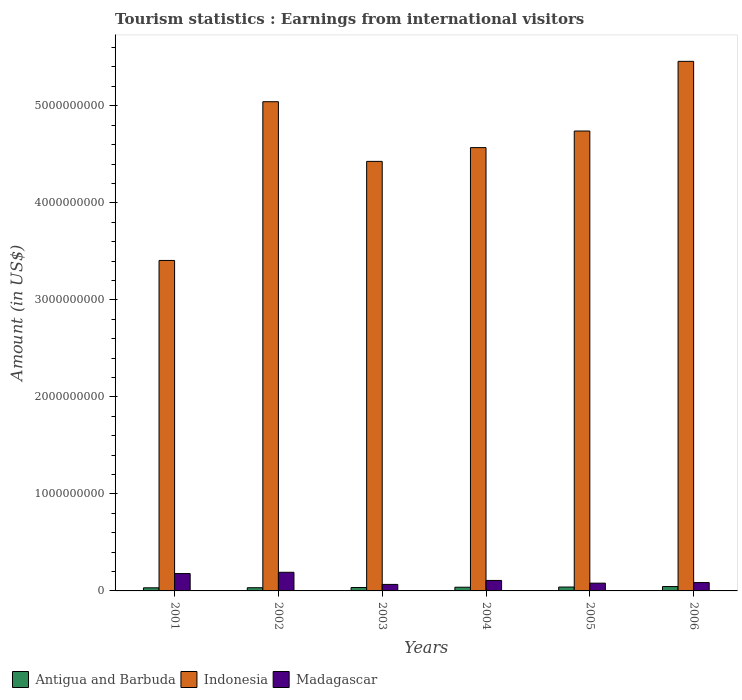How many groups of bars are there?
Keep it short and to the point. 6. How many bars are there on the 3rd tick from the right?
Keep it short and to the point. 3. What is the label of the 3rd group of bars from the left?
Your answer should be very brief. 2003. In how many cases, is the number of bars for a given year not equal to the number of legend labels?
Keep it short and to the point. 0. What is the earnings from international visitors in Indonesia in 2003?
Your answer should be compact. 4.43e+09. Across all years, what is the maximum earnings from international visitors in Antigua and Barbuda?
Provide a succinct answer. 4.50e+07. Across all years, what is the minimum earnings from international visitors in Madagascar?
Make the answer very short. 6.70e+07. What is the total earnings from international visitors in Antigua and Barbuda in the graph?
Your response must be concise. 2.23e+08. What is the difference between the earnings from international visitors in Indonesia in 2001 and that in 2003?
Your answer should be compact. -1.02e+09. What is the difference between the earnings from international visitors in Antigua and Barbuda in 2005 and the earnings from international visitors in Indonesia in 2003?
Offer a terse response. -4.39e+09. What is the average earnings from international visitors in Antigua and Barbuda per year?
Keep it short and to the point. 3.72e+07. In the year 2006, what is the difference between the earnings from international visitors in Antigua and Barbuda and earnings from international visitors in Madagascar?
Make the answer very short. -4.10e+07. In how many years, is the earnings from international visitors in Madagascar greater than 200000000 US$?
Ensure brevity in your answer.  0. What is the ratio of the earnings from international visitors in Madagascar in 2002 to that in 2006?
Your answer should be very brief. 2.23. Is the earnings from international visitors in Madagascar in 2004 less than that in 2005?
Provide a short and direct response. No. Is the difference between the earnings from international visitors in Antigua and Barbuda in 2002 and 2004 greater than the difference between the earnings from international visitors in Madagascar in 2002 and 2004?
Offer a very short reply. No. What is the difference between the highest and the lowest earnings from international visitors in Indonesia?
Offer a very short reply. 2.05e+09. What does the 3rd bar from the left in 2002 represents?
Give a very brief answer. Madagascar. What does the 1st bar from the right in 2006 represents?
Your answer should be compact. Madagascar. Is it the case that in every year, the sum of the earnings from international visitors in Antigua and Barbuda and earnings from international visitors in Madagascar is greater than the earnings from international visitors in Indonesia?
Your answer should be very brief. No. How many years are there in the graph?
Give a very brief answer. 6. What is the difference between two consecutive major ticks on the Y-axis?
Offer a very short reply. 1.00e+09. Does the graph contain any zero values?
Your response must be concise. No. Does the graph contain grids?
Your answer should be very brief. No. How many legend labels are there?
Keep it short and to the point. 3. What is the title of the graph?
Provide a succinct answer. Tourism statistics : Earnings from international visitors. What is the Amount (in US$) in Antigua and Barbuda in 2001?
Your answer should be very brief. 3.20e+07. What is the Amount (in US$) of Indonesia in 2001?
Your response must be concise. 3.41e+09. What is the Amount (in US$) of Madagascar in 2001?
Provide a short and direct response. 1.79e+08. What is the Amount (in US$) in Antigua and Barbuda in 2002?
Provide a succinct answer. 3.30e+07. What is the Amount (in US$) of Indonesia in 2002?
Provide a succinct answer. 5.04e+09. What is the Amount (in US$) of Madagascar in 2002?
Your answer should be compact. 1.92e+08. What is the Amount (in US$) in Antigua and Barbuda in 2003?
Give a very brief answer. 3.50e+07. What is the Amount (in US$) of Indonesia in 2003?
Make the answer very short. 4.43e+09. What is the Amount (in US$) of Madagascar in 2003?
Ensure brevity in your answer.  6.70e+07. What is the Amount (in US$) in Antigua and Barbuda in 2004?
Your response must be concise. 3.80e+07. What is the Amount (in US$) in Indonesia in 2004?
Make the answer very short. 4.57e+09. What is the Amount (in US$) in Madagascar in 2004?
Provide a short and direct response. 1.08e+08. What is the Amount (in US$) of Antigua and Barbuda in 2005?
Make the answer very short. 4.00e+07. What is the Amount (in US$) in Indonesia in 2005?
Your answer should be very brief. 4.74e+09. What is the Amount (in US$) of Madagascar in 2005?
Offer a terse response. 8.00e+07. What is the Amount (in US$) of Antigua and Barbuda in 2006?
Ensure brevity in your answer.  4.50e+07. What is the Amount (in US$) of Indonesia in 2006?
Offer a very short reply. 5.46e+09. What is the Amount (in US$) of Madagascar in 2006?
Provide a short and direct response. 8.60e+07. Across all years, what is the maximum Amount (in US$) of Antigua and Barbuda?
Ensure brevity in your answer.  4.50e+07. Across all years, what is the maximum Amount (in US$) of Indonesia?
Offer a terse response. 5.46e+09. Across all years, what is the maximum Amount (in US$) of Madagascar?
Offer a very short reply. 1.92e+08. Across all years, what is the minimum Amount (in US$) of Antigua and Barbuda?
Keep it short and to the point. 3.20e+07. Across all years, what is the minimum Amount (in US$) in Indonesia?
Keep it short and to the point. 3.41e+09. Across all years, what is the minimum Amount (in US$) in Madagascar?
Provide a succinct answer. 6.70e+07. What is the total Amount (in US$) in Antigua and Barbuda in the graph?
Your answer should be compact. 2.23e+08. What is the total Amount (in US$) of Indonesia in the graph?
Your answer should be compact. 2.76e+1. What is the total Amount (in US$) of Madagascar in the graph?
Offer a terse response. 7.12e+08. What is the difference between the Amount (in US$) in Antigua and Barbuda in 2001 and that in 2002?
Ensure brevity in your answer.  -1.00e+06. What is the difference between the Amount (in US$) in Indonesia in 2001 and that in 2002?
Your response must be concise. -1.64e+09. What is the difference between the Amount (in US$) of Madagascar in 2001 and that in 2002?
Offer a terse response. -1.30e+07. What is the difference between the Amount (in US$) of Antigua and Barbuda in 2001 and that in 2003?
Ensure brevity in your answer.  -3.00e+06. What is the difference between the Amount (in US$) of Indonesia in 2001 and that in 2003?
Ensure brevity in your answer.  -1.02e+09. What is the difference between the Amount (in US$) of Madagascar in 2001 and that in 2003?
Your response must be concise. 1.12e+08. What is the difference between the Amount (in US$) in Antigua and Barbuda in 2001 and that in 2004?
Give a very brief answer. -6.00e+06. What is the difference between the Amount (in US$) in Indonesia in 2001 and that in 2004?
Make the answer very short. -1.16e+09. What is the difference between the Amount (in US$) of Madagascar in 2001 and that in 2004?
Keep it short and to the point. 7.10e+07. What is the difference between the Amount (in US$) in Antigua and Barbuda in 2001 and that in 2005?
Your answer should be very brief. -8.00e+06. What is the difference between the Amount (in US$) of Indonesia in 2001 and that in 2005?
Your response must be concise. -1.33e+09. What is the difference between the Amount (in US$) in Madagascar in 2001 and that in 2005?
Your answer should be very brief. 9.90e+07. What is the difference between the Amount (in US$) of Antigua and Barbuda in 2001 and that in 2006?
Ensure brevity in your answer.  -1.30e+07. What is the difference between the Amount (in US$) of Indonesia in 2001 and that in 2006?
Your answer should be very brief. -2.05e+09. What is the difference between the Amount (in US$) of Madagascar in 2001 and that in 2006?
Ensure brevity in your answer.  9.30e+07. What is the difference between the Amount (in US$) of Indonesia in 2002 and that in 2003?
Provide a succinct answer. 6.15e+08. What is the difference between the Amount (in US$) in Madagascar in 2002 and that in 2003?
Ensure brevity in your answer.  1.25e+08. What is the difference between the Amount (in US$) of Antigua and Barbuda in 2002 and that in 2004?
Your response must be concise. -5.00e+06. What is the difference between the Amount (in US$) in Indonesia in 2002 and that in 2004?
Your answer should be very brief. 4.73e+08. What is the difference between the Amount (in US$) of Madagascar in 2002 and that in 2004?
Provide a succinct answer. 8.40e+07. What is the difference between the Amount (in US$) of Antigua and Barbuda in 2002 and that in 2005?
Keep it short and to the point. -7.00e+06. What is the difference between the Amount (in US$) of Indonesia in 2002 and that in 2005?
Provide a succinct answer. 3.02e+08. What is the difference between the Amount (in US$) in Madagascar in 2002 and that in 2005?
Offer a terse response. 1.12e+08. What is the difference between the Amount (in US$) in Antigua and Barbuda in 2002 and that in 2006?
Ensure brevity in your answer.  -1.20e+07. What is the difference between the Amount (in US$) in Indonesia in 2002 and that in 2006?
Ensure brevity in your answer.  -4.16e+08. What is the difference between the Amount (in US$) of Madagascar in 2002 and that in 2006?
Make the answer very short. 1.06e+08. What is the difference between the Amount (in US$) in Indonesia in 2003 and that in 2004?
Make the answer very short. -1.42e+08. What is the difference between the Amount (in US$) in Madagascar in 2003 and that in 2004?
Offer a terse response. -4.10e+07. What is the difference between the Amount (in US$) in Antigua and Barbuda in 2003 and that in 2005?
Give a very brief answer. -5.00e+06. What is the difference between the Amount (in US$) of Indonesia in 2003 and that in 2005?
Provide a short and direct response. -3.13e+08. What is the difference between the Amount (in US$) of Madagascar in 2003 and that in 2005?
Give a very brief answer. -1.30e+07. What is the difference between the Amount (in US$) of Antigua and Barbuda in 2003 and that in 2006?
Offer a very short reply. -1.00e+07. What is the difference between the Amount (in US$) of Indonesia in 2003 and that in 2006?
Provide a short and direct response. -1.03e+09. What is the difference between the Amount (in US$) of Madagascar in 2003 and that in 2006?
Offer a terse response. -1.90e+07. What is the difference between the Amount (in US$) in Antigua and Barbuda in 2004 and that in 2005?
Provide a short and direct response. -2.00e+06. What is the difference between the Amount (in US$) in Indonesia in 2004 and that in 2005?
Provide a succinct answer. -1.71e+08. What is the difference between the Amount (in US$) of Madagascar in 2004 and that in 2005?
Keep it short and to the point. 2.80e+07. What is the difference between the Amount (in US$) of Antigua and Barbuda in 2004 and that in 2006?
Provide a short and direct response. -7.00e+06. What is the difference between the Amount (in US$) in Indonesia in 2004 and that in 2006?
Your response must be concise. -8.89e+08. What is the difference between the Amount (in US$) of Madagascar in 2004 and that in 2006?
Offer a very short reply. 2.20e+07. What is the difference between the Amount (in US$) in Antigua and Barbuda in 2005 and that in 2006?
Your answer should be very brief. -5.00e+06. What is the difference between the Amount (in US$) of Indonesia in 2005 and that in 2006?
Make the answer very short. -7.18e+08. What is the difference between the Amount (in US$) of Madagascar in 2005 and that in 2006?
Offer a terse response. -6.00e+06. What is the difference between the Amount (in US$) of Antigua and Barbuda in 2001 and the Amount (in US$) of Indonesia in 2002?
Ensure brevity in your answer.  -5.01e+09. What is the difference between the Amount (in US$) in Antigua and Barbuda in 2001 and the Amount (in US$) in Madagascar in 2002?
Make the answer very short. -1.60e+08. What is the difference between the Amount (in US$) in Indonesia in 2001 and the Amount (in US$) in Madagascar in 2002?
Ensure brevity in your answer.  3.21e+09. What is the difference between the Amount (in US$) in Antigua and Barbuda in 2001 and the Amount (in US$) in Indonesia in 2003?
Your answer should be compact. -4.40e+09. What is the difference between the Amount (in US$) in Antigua and Barbuda in 2001 and the Amount (in US$) in Madagascar in 2003?
Your answer should be compact. -3.50e+07. What is the difference between the Amount (in US$) in Indonesia in 2001 and the Amount (in US$) in Madagascar in 2003?
Give a very brief answer. 3.34e+09. What is the difference between the Amount (in US$) of Antigua and Barbuda in 2001 and the Amount (in US$) of Indonesia in 2004?
Your answer should be very brief. -4.54e+09. What is the difference between the Amount (in US$) of Antigua and Barbuda in 2001 and the Amount (in US$) of Madagascar in 2004?
Make the answer very short. -7.60e+07. What is the difference between the Amount (in US$) in Indonesia in 2001 and the Amount (in US$) in Madagascar in 2004?
Offer a very short reply. 3.30e+09. What is the difference between the Amount (in US$) of Antigua and Barbuda in 2001 and the Amount (in US$) of Indonesia in 2005?
Ensure brevity in your answer.  -4.71e+09. What is the difference between the Amount (in US$) of Antigua and Barbuda in 2001 and the Amount (in US$) of Madagascar in 2005?
Make the answer very short. -4.80e+07. What is the difference between the Amount (in US$) in Indonesia in 2001 and the Amount (in US$) in Madagascar in 2005?
Give a very brief answer. 3.33e+09. What is the difference between the Amount (in US$) of Antigua and Barbuda in 2001 and the Amount (in US$) of Indonesia in 2006?
Make the answer very short. -5.43e+09. What is the difference between the Amount (in US$) in Antigua and Barbuda in 2001 and the Amount (in US$) in Madagascar in 2006?
Ensure brevity in your answer.  -5.40e+07. What is the difference between the Amount (in US$) in Indonesia in 2001 and the Amount (in US$) in Madagascar in 2006?
Your response must be concise. 3.32e+09. What is the difference between the Amount (in US$) in Antigua and Barbuda in 2002 and the Amount (in US$) in Indonesia in 2003?
Give a very brief answer. -4.39e+09. What is the difference between the Amount (in US$) in Antigua and Barbuda in 2002 and the Amount (in US$) in Madagascar in 2003?
Your answer should be compact. -3.40e+07. What is the difference between the Amount (in US$) of Indonesia in 2002 and the Amount (in US$) of Madagascar in 2003?
Your response must be concise. 4.98e+09. What is the difference between the Amount (in US$) of Antigua and Barbuda in 2002 and the Amount (in US$) of Indonesia in 2004?
Keep it short and to the point. -4.54e+09. What is the difference between the Amount (in US$) of Antigua and Barbuda in 2002 and the Amount (in US$) of Madagascar in 2004?
Your response must be concise. -7.50e+07. What is the difference between the Amount (in US$) of Indonesia in 2002 and the Amount (in US$) of Madagascar in 2004?
Give a very brief answer. 4.93e+09. What is the difference between the Amount (in US$) of Antigua and Barbuda in 2002 and the Amount (in US$) of Indonesia in 2005?
Make the answer very short. -4.71e+09. What is the difference between the Amount (in US$) in Antigua and Barbuda in 2002 and the Amount (in US$) in Madagascar in 2005?
Ensure brevity in your answer.  -4.70e+07. What is the difference between the Amount (in US$) of Indonesia in 2002 and the Amount (in US$) of Madagascar in 2005?
Make the answer very short. 4.96e+09. What is the difference between the Amount (in US$) in Antigua and Barbuda in 2002 and the Amount (in US$) in Indonesia in 2006?
Provide a short and direct response. -5.42e+09. What is the difference between the Amount (in US$) in Antigua and Barbuda in 2002 and the Amount (in US$) in Madagascar in 2006?
Provide a succinct answer. -5.30e+07. What is the difference between the Amount (in US$) in Indonesia in 2002 and the Amount (in US$) in Madagascar in 2006?
Make the answer very short. 4.96e+09. What is the difference between the Amount (in US$) in Antigua and Barbuda in 2003 and the Amount (in US$) in Indonesia in 2004?
Provide a short and direct response. -4.53e+09. What is the difference between the Amount (in US$) in Antigua and Barbuda in 2003 and the Amount (in US$) in Madagascar in 2004?
Your answer should be compact. -7.30e+07. What is the difference between the Amount (in US$) of Indonesia in 2003 and the Amount (in US$) of Madagascar in 2004?
Offer a terse response. 4.32e+09. What is the difference between the Amount (in US$) in Antigua and Barbuda in 2003 and the Amount (in US$) in Indonesia in 2005?
Your response must be concise. -4.70e+09. What is the difference between the Amount (in US$) of Antigua and Barbuda in 2003 and the Amount (in US$) of Madagascar in 2005?
Your answer should be compact. -4.50e+07. What is the difference between the Amount (in US$) in Indonesia in 2003 and the Amount (in US$) in Madagascar in 2005?
Provide a short and direct response. 4.35e+09. What is the difference between the Amount (in US$) in Antigua and Barbuda in 2003 and the Amount (in US$) in Indonesia in 2006?
Offer a very short reply. -5.42e+09. What is the difference between the Amount (in US$) of Antigua and Barbuda in 2003 and the Amount (in US$) of Madagascar in 2006?
Your response must be concise. -5.10e+07. What is the difference between the Amount (in US$) of Indonesia in 2003 and the Amount (in US$) of Madagascar in 2006?
Your answer should be compact. 4.34e+09. What is the difference between the Amount (in US$) in Antigua and Barbuda in 2004 and the Amount (in US$) in Indonesia in 2005?
Give a very brief answer. -4.70e+09. What is the difference between the Amount (in US$) in Antigua and Barbuda in 2004 and the Amount (in US$) in Madagascar in 2005?
Offer a terse response. -4.20e+07. What is the difference between the Amount (in US$) of Indonesia in 2004 and the Amount (in US$) of Madagascar in 2005?
Offer a terse response. 4.49e+09. What is the difference between the Amount (in US$) in Antigua and Barbuda in 2004 and the Amount (in US$) in Indonesia in 2006?
Provide a succinct answer. -5.42e+09. What is the difference between the Amount (in US$) in Antigua and Barbuda in 2004 and the Amount (in US$) in Madagascar in 2006?
Offer a terse response. -4.80e+07. What is the difference between the Amount (in US$) of Indonesia in 2004 and the Amount (in US$) of Madagascar in 2006?
Ensure brevity in your answer.  4.48e+09. What is the difference between the Amount (in US$) of Antigua and Barbuda in 2005 and the Amount (in US$) of Indonesia in 2006?
Your response must be concise. -5.42e+09. What is the difference between the Amount (in US$) of Antigua and Barbuda in 2005 and the Amount (in US$) of Madagascar in 2006?
Offer a very short reply. -4.60e+07. What is the difference between the Amount (in US$) of Indonesia in 2005 and the Amount (in US$) of Madagascar in 2006?
Provide a short and direct response. 4.65e+09. What is the average Amount (in US$) of Antigua and Barbuda per year?
Keep it short and to the point. 3.72e+07. What is the average Amount (in US$) in Indonesia per year?
Provide a succinct answer. 4.61e+09. What is the average Amount (in US$) in Madagascar per year?
Offer a terse response. 1.19e+08. In the year 2001, what is the difference between the Amount (in US$) of Antigua and Barbuda and Amount (in US$) of Indonesia?
Offer a terse response. -3.37e+09. In the year 2001, what is the difference between the Amount (in US$) of Antigua and Barbuda and Amount (in US$) of Madagascar?
Ensure brevity in your answer.  -1.47e+08. In the year 2001, what is the difference between the Amount (in US$) in Indonesia and Amount (in US$) in Madagascar?
Keep it short and to the point. 3.23e+09. In the year 2002, what is the difference between the Amount (in US$) of Antigua and Barbuda and Amount (in US$) of Indonesia?
Offer a terse response. -5.01e+09. In the year 2002, what is the difference between the Amount (in US$) of Antigua and Barbuda and Amount (in US$) of Madagascar?
Provide a short and direct response. -1.59e+08. In the year 2002, what is the difference between the Amount (in US$) in Indonesia and Amount (in US$) in Madagascar?
Offer a terse response. 4.85e+09. In the year 2003, what is the difference between the Amount (in US$) of Antigua and Barbuda and Amount (in US$) of Indonesia?
Keep it short and to the point. -4.39e+09. In the year 2003, what is the difference between the Amount (in US$) of Antigua and Barbuda and Amount (in US$) of Madagascar?
Your answer should be compact. -3.20e+07. In the year 2003, what is the difference between the Amount (in US$) of Indonesia and Amount (in US$) of Madagascar?
Ensure brevity in your answer.  4.36e+09. In the year 2004, what is the difference between the Amount (in US$) in Antigua and Barbuda and Amount (in US$) in Indonesia?
Offer a very short reply. -4.53e+09. In the year 2004, what is the difference between the Amount (in US$) of Antigua and Barbuda and Amount (in US$) of Madagascar?
Offer a terse response. -7.00e+07. In the year 2004, what is the difference between the Amount (in US$) in Indonesia and Amount (in US$) in Madagascar?
Keep it short and to the point. 4.46e+09. In the year 2005, what is the difference between the Amount (in US$) of Antigua and Barbuda and Amount (in US$) of Indonesia?
Your answer should be very brief. -4.70e+09. In the year 2005, what is the difference between the Amount (in US$) of Antigua and Barbuda and Amount (in US$) of Madagascar?
Ensure brevity in your answer.  -4.00e+07. In the year 2005, what is the difference between the Amount (in US$) of Indonesia and Amount (in US$) of Madagascar?
Make the answer very short. 4.66e+09. In the year 2006, what is the difference between the Amount (in US$) in Antigua and Barbuda and Amount (in US$) in Indonesia?
Give a very brief answer. -5.41e+09. In the year 2006, what is the difference between the Amount (in US$) of Antigua and Barbuda and Amount (in US$) of Madagascar?
Keep it short and to the point. -4.10e+07. In the year 2006, what is the difference between the Amount (in US$) of Indonesia and Amount (in US$) of Madagascar?
Provide a short and direct response. 5.37e+09. What is the ratio of the Amount (in US$) in Antigua and Barbuda in 2001 to that in 2002?
Ensure brevity in your answer.  0.97. What is the ratio of the Amount (in US$) of Indonesia in 2001 to that in 2002?
Offer a very short reply. 0.68. What is the ratio of the Amount (in US$) of Madagascar in 2001 to that in 2002?
Provide a succinct answer. 0.93. What is the ratio of the Amount (in US$) of Antigua and Barbuda in 2001 to that in 2003?
Provide a short and direct response. 0.91. What is the ratio of the Amount (in US$) in Indonesia in 2001 to that in 2003?
Ensure brevity in your answer.  0.77. What is the ratio of the Amount (in US$) of Madagascar in 2001 to that in 2003?
Your response must be concise. 2.67. What is the ratio of the Amount (in US$) in Antigua and Barbuda in 2001 to that in 2004?
Ensure brevity in your answer.  0.84. What is the ratio of the Amount (in US$) of Indonesia in 2001 to that in 2004?
Your response must be concise. 0.75. What is the ratio of the Amount (in US$) of Madagascar in 2001 to that in 2004?
Provide a short and direct response. 1.66. What is the ratio of the Amount (in US$) of Indonesia in 2001 to that in 2005?
Your response must be concise. 0.72. What is the ratio of the Amount (in US$) of Madagascar in 2001 to that in 2005?
Give a very brief answer. 2.24. What is the ratio of the Amount (in US$) in Antigua and Barbuda in 2001 to that in 2006?
Your answer should be very brief. 0.71. What is the ratio of the Amount (in US$) in Indonesia in 2001 to that in 2006?
Give a very brief answer. 0.62. What is the ratio of the Amount (in US$) in Madagascar in 2001 to that in 2006?
Your answer should be compact. 2.08. What is the ratio of the Amount (in US$) in Antigua and Barbuda in 2002 to that in 2003?
Provide a short and direct response. 0.94. What is the ratio of the Amount (in US$) of Indonesia in 2002 to that in 2003?
Ensure brevity in your answer.  1.14. What is the ratio of the Amount (in US$) in Madagascar in 2002 to that in 2003?
Your answer should be very brief. 2.87. What is the ratio of the Amount (in US$) of Antigua and Barbuda in 2002 to that in 2004?
Your answer should be compact. 0.87. What is the ratio of the Amount (in US$) of Indonesia in 2002 to that in 2004?
Make the answer very short. 1.1. What is the ratio of the Amount (in US$) in Madagascar in 2002 to that in 2004?
Your answer should be compact. 1.78. What is the ratio of the Amount (in US$) in Antigua and Barbuda in 2002 to that in 2005?
Offer a very short reply. 0.82. What is the ratio of the Amount (in US$) in Indonesia in 2002 to that in 2005?
Offer a terse response. 1.06. What is the ratio of the Amount (in US$) in Antigua and Barbuda in 2002 to that in 2006?
Your answer should be very brief. 0.73. What is the ratio of the Amount (in US$) in Indonesia in 2002 to that in 2006?
Ensure brevity in your answer.  0.92. What is the ratio of the Amount (in US$) in Madagascar in 2002 to that in 2006?
Give a very brief answer. 2.23. What is the ratio of the Amount (in US$) in Antigua and Barbuda in 2003 to that in 2004?
Your answer should be compact. 0.92. What is the ratio of the Amount (in US$) in Indonesia in 2003 to that in 2004?
Keep it short and to the point. 0.97. What is the ratio of the Amount (in US$) of Madagascar in 2003 to that in 2004?
Your response must be concise. 0.62. What is the ratio of the Amount (in US$) of Antigua and Barbuda in 2003 to that in 2005?
Make the answer very short. 0.88. What is the ratio of the Amount (in US$) of Indonesia in 2003 to that in 2005?
Offer a very short reply. 0.93. What is the ratio of the Amount (in US$) in Madagascar in 2003 to that in 2005?
Ensure brevity in your answer.  0.84. What is the ratio of the Amount (in US$) of Indonesia in 2003 to that in 2006?
Ensure brevity in your answer.  0.81. What is the ratio of the Amount (in US$) in Madagascar in 2003 to that in 2006?
Provide a short and direct response. 0.78. What is the ratio of the Amount (in US$) of Indonesia in 2004 to that in 2005?
Your answer should be very brief. 0.96. What is the ratio of the Amount (in US$) in Madagascar in 2004 to that in 2005?
Offer a terse response. 1.35. What is the ratio of the Amount (in US$) in Antigua and Barbuda in 2004 to that in 2006?
Give a very brief answer. 0.84. What is the ratio of the Amount (in US$) of Indonesia in 2004 to that in 2006?
Give a very brief answer. 0.84. What is the ratio of the Amount (in US$) in Madagascar in 2004 to that in 2006?
Your answer should be very brief. 1.26. What is the ratio of the Amount (in US$) in Antigua and Barbuda in 2005 to that in 2006?
Make the answer very short. 0.89. What is the ratio of the Amount (in US$) in Indonesia in 2005 to that in 2006?
Make the answer very short. 0.87. What is the ratio of the Amount (in US$) of Madagascar in 2005 to that in 2006?
Give a very brief answer. 0.93. What is the difference between the highest and the second highest Amount (in US$) of Antigua and Barbuda?
Provide a short and direct response. 5.00e+06. What is the difference between the highest and the second highest Amount (in US$) in Indonesia?
Offer a terse response. 4.16e+08. What is the difference between the highest and the second highest Amount (in US$) in Madagascar?
Keep it short and to the point. 1.30e+07. What is the difference between the highest and the lowest Amount (in US$) of Antigua and Barbuda?
Give a very brief answer. 1.30e+07. What is the difference between the highest and the lowest Amount (in US$) of Indonesia?
Your answer should be very brief. 2.05e+09. What is the difference between the highest and the lowest Amount (in US$) in Madagascar?
Your response must be concise. 1.25e+08. 